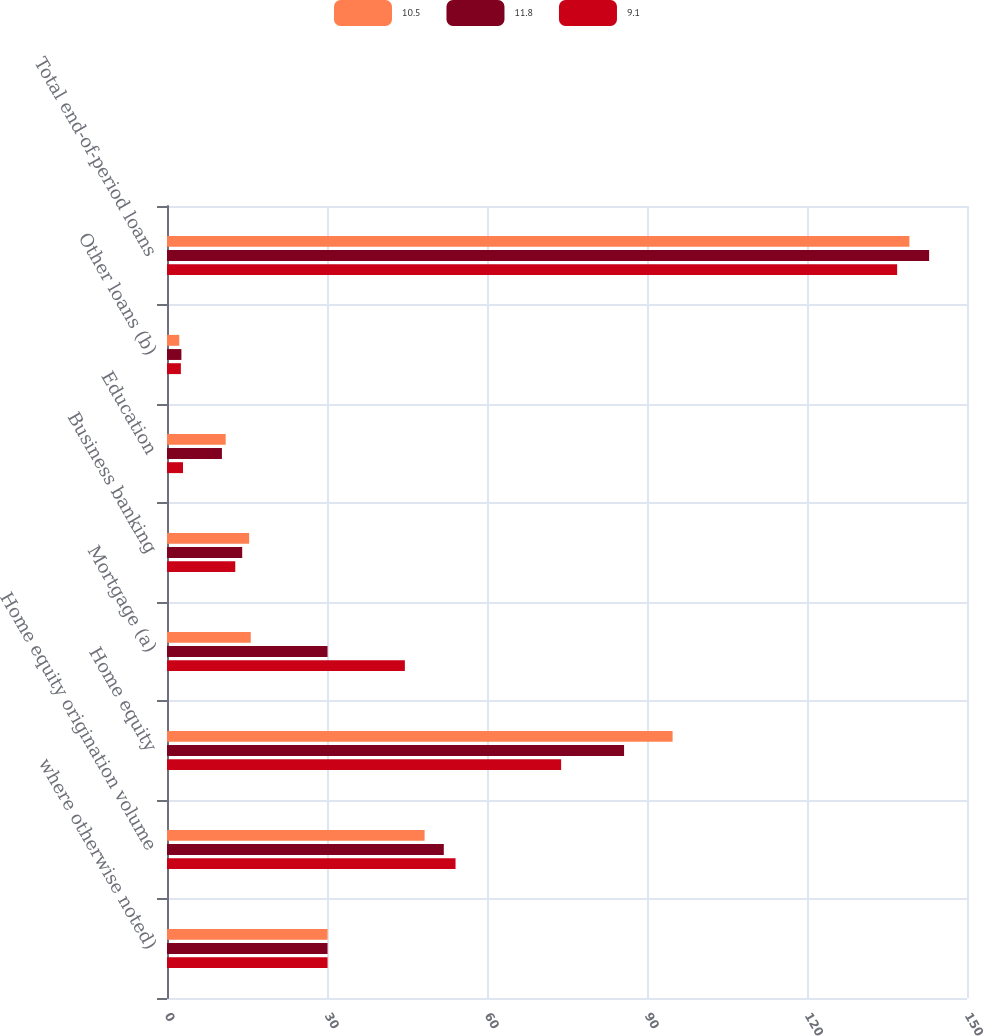<chart> <loc_0><loc_0><loc_500><loc_500><stacked_bar_chart><ecel><fcel>where otherwise noted)<fcel>Home equity origination volume<fcel>Home equity<fcel>Mortgage (a)<fcel>Business banking<fcel>Education<fcel>Other loans (b)<fcel>Total end-of-period loans<nl><fcel>10.5<fcel>30.1<fcel>48.3<fcel>94.8<fcel>15.7<fcel>15.4<fcel>11<fcel>2.3<fcel>139.2<nl><fcel>11.8<fcel>30.1<fcel>51.9<fcel>85.7<fcel>30.1<fcel>14.1<fcel>10.3<fcel>2.7<fcel>142.9<nl><fcel>9.1<fcel>30.1<fcel>54.1<fcel>73.9<fcel>44.6<fcel>12.8<fcel>3<fcel>2.6<fcel>136.9<nl></chart> 